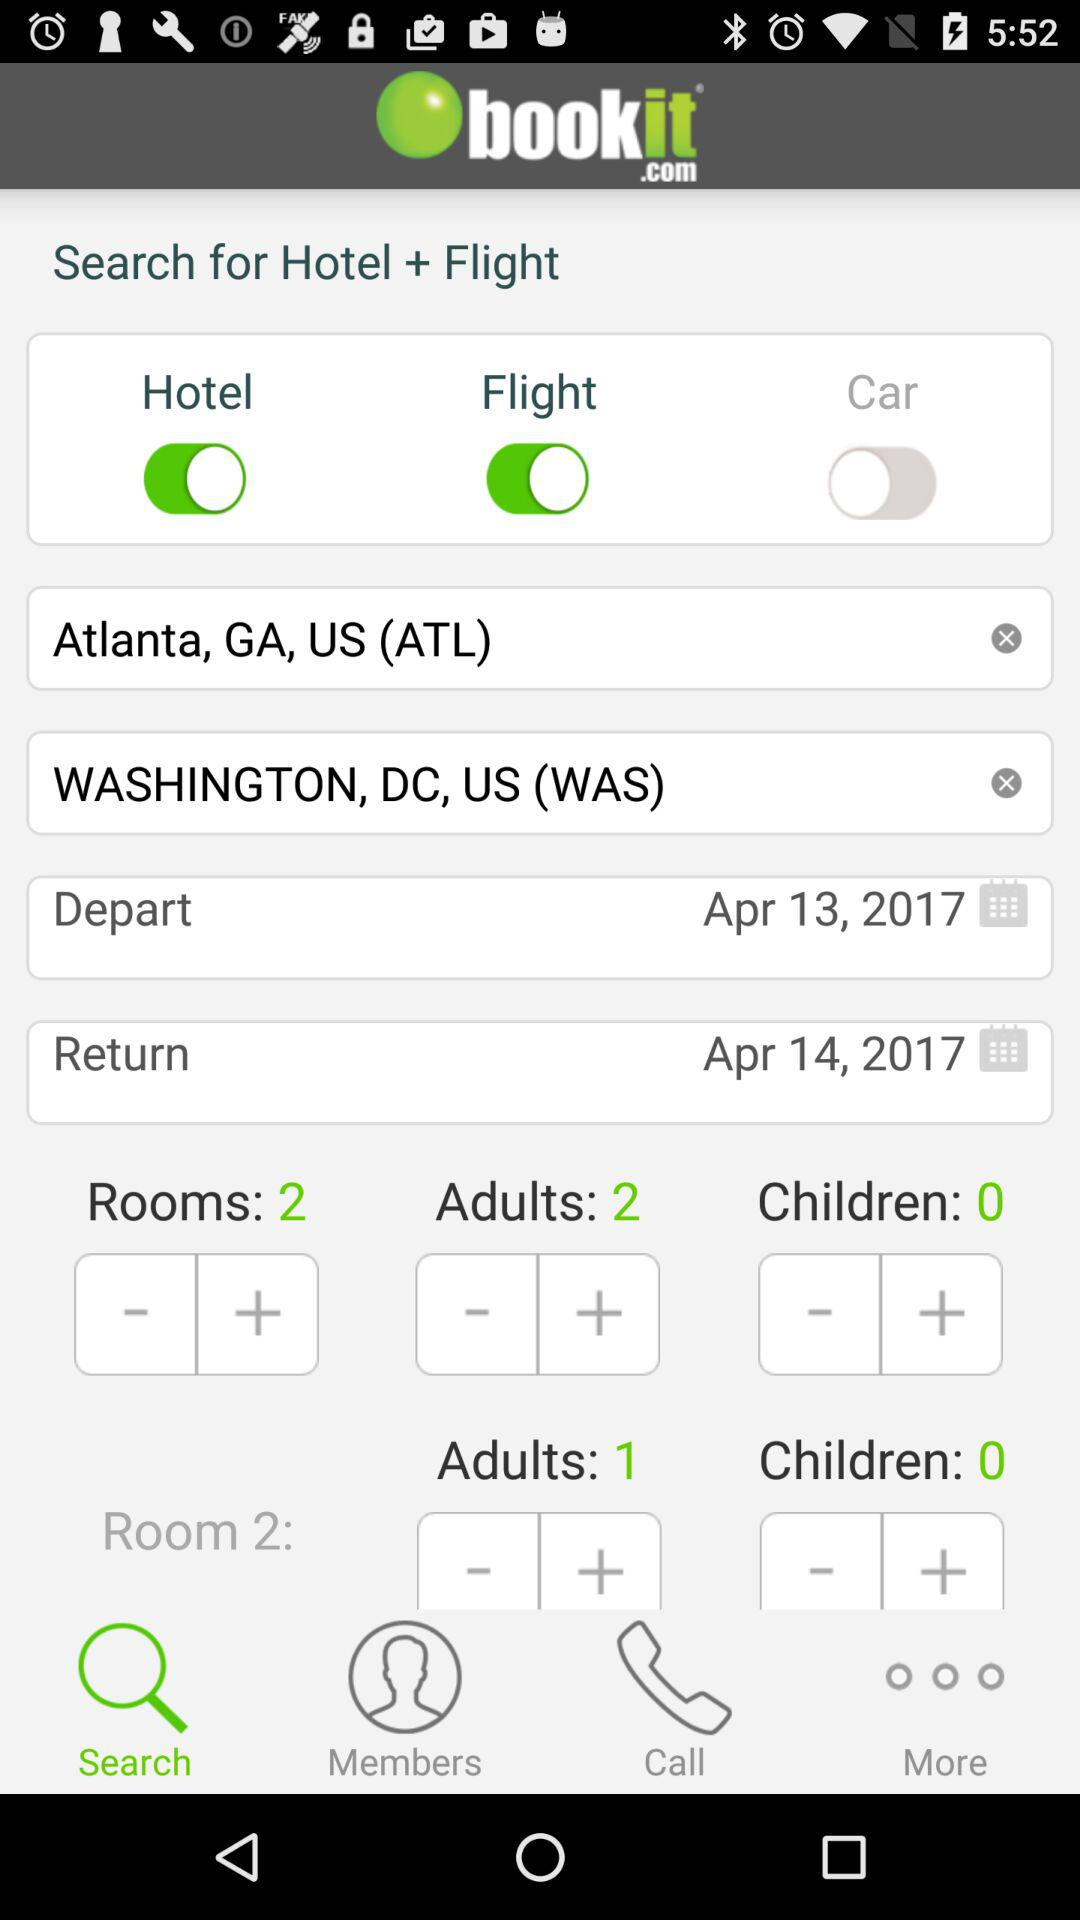What is the status of "Hotel"? The status is "on". 